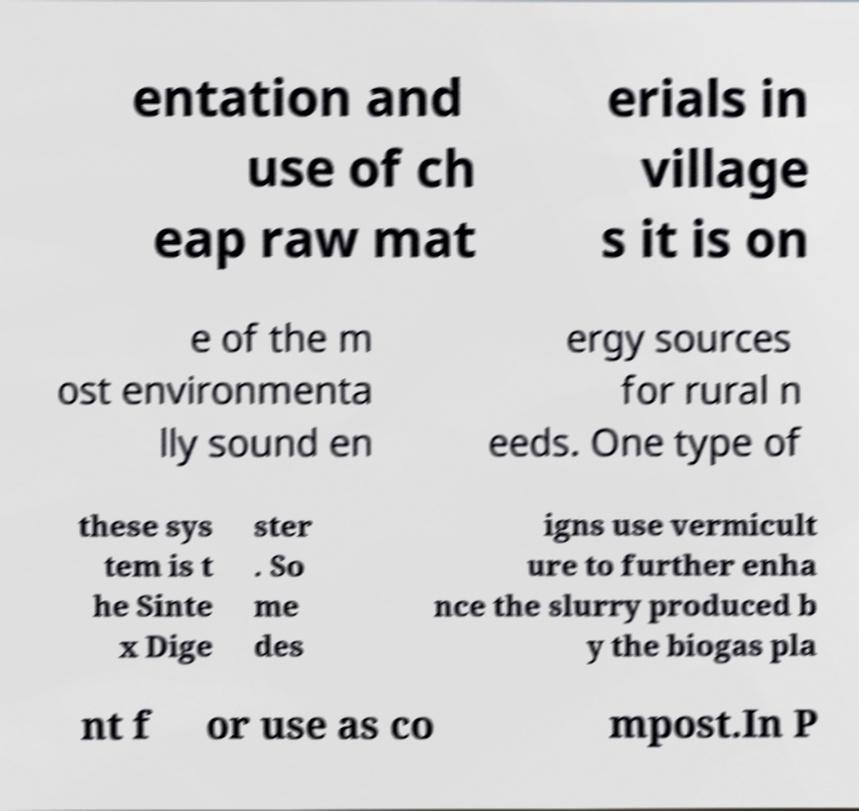For documentation purposes, I need the text within this image transcribed. Could you provide that? entation and use of ch eap raw mat erials in village s it is on e of the m ost environmenta lly sound en ergy sources for rural n eeds. One type of these sys tem is t he Sinte x Dige ster . So me des igns use vermicult ure to further enha nce the slurry produced b y the biogas pla nt f or use as co mpost.In P 